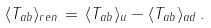Convert formula to latex. <formula><loc_0><loc_0><loc_500><loc_500>\langle T _ { a b } \rangle _ { r e n } \, = \, \langle T _ { a b } \rangle _ { u } - \langle T _ { a b } \rangle _ { a d } \, .</formula> 